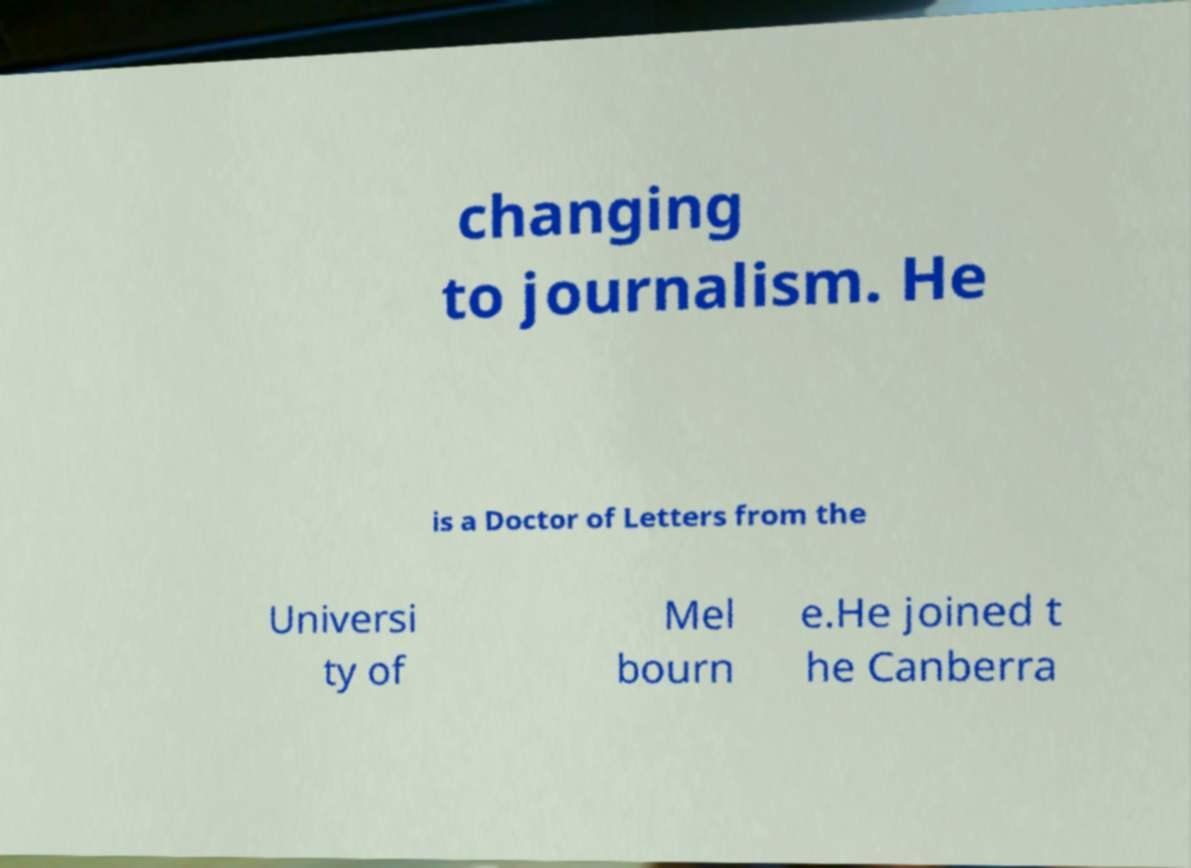Could you assist in decoding the text presented in this image and type it out clearly? changing to journalism. He is a Doctor of Letters from the Universi ty of Mel bourn e.He joined t he Canberra 